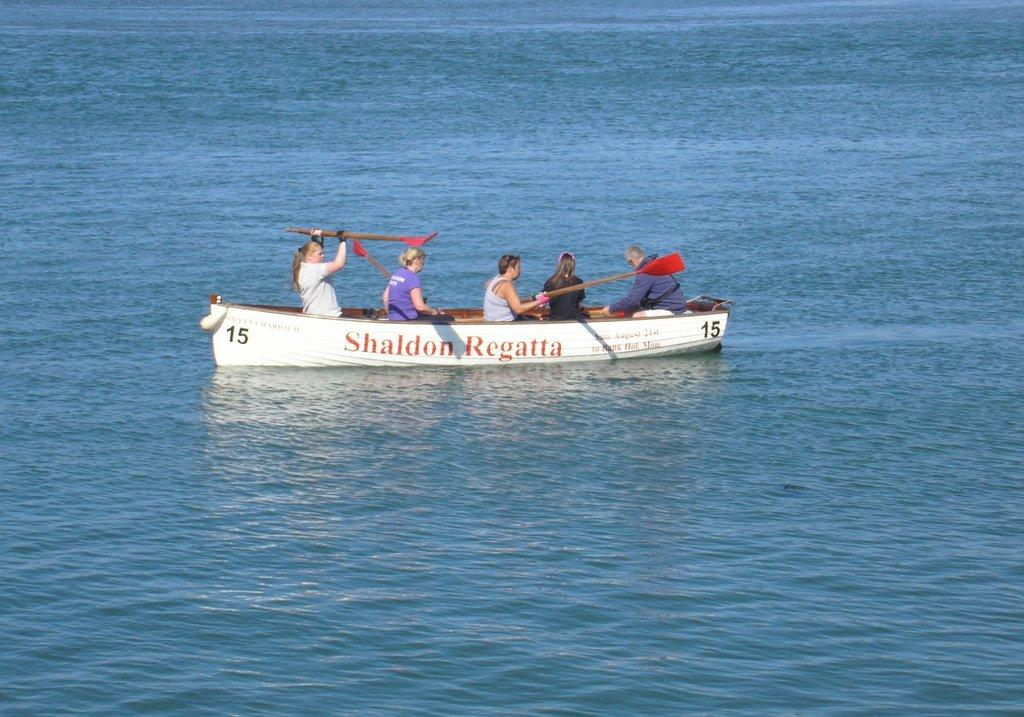Who or what is present in the image? There are people in the image. What are the people doing in the image? The people are holding objects and sitting in a boat. Where is the boat located in the image? The boat is on a river. Can you see a snake slithering in the water near the boat in the image? There is no snake present in the image; it only shows people sitting in a boat on a river. 